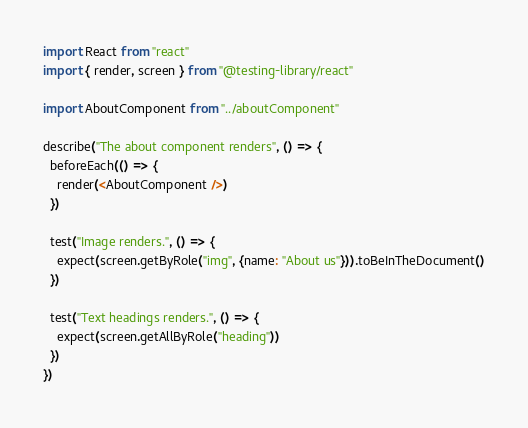Convert code to text. <code><loc_0><loc_0><loc_500><loc_500><_JavaScript_>import React from "react"
import { render, screen } from "@testing-library/react"

import AboutComponent from "../aboutComponent"

describe("The about component renders", () => {
  beforeEach(() => {
    render(<AboutComponent />)
  })

  test("Image renders.", () => {
    expect(screen.getByRole("img", {name: "About us"})).toBeInTheDocument()
  })

  test("Text headings renders.", () => {
    expect(screen.getAllByRole("heading"))
  })
})
</code> 